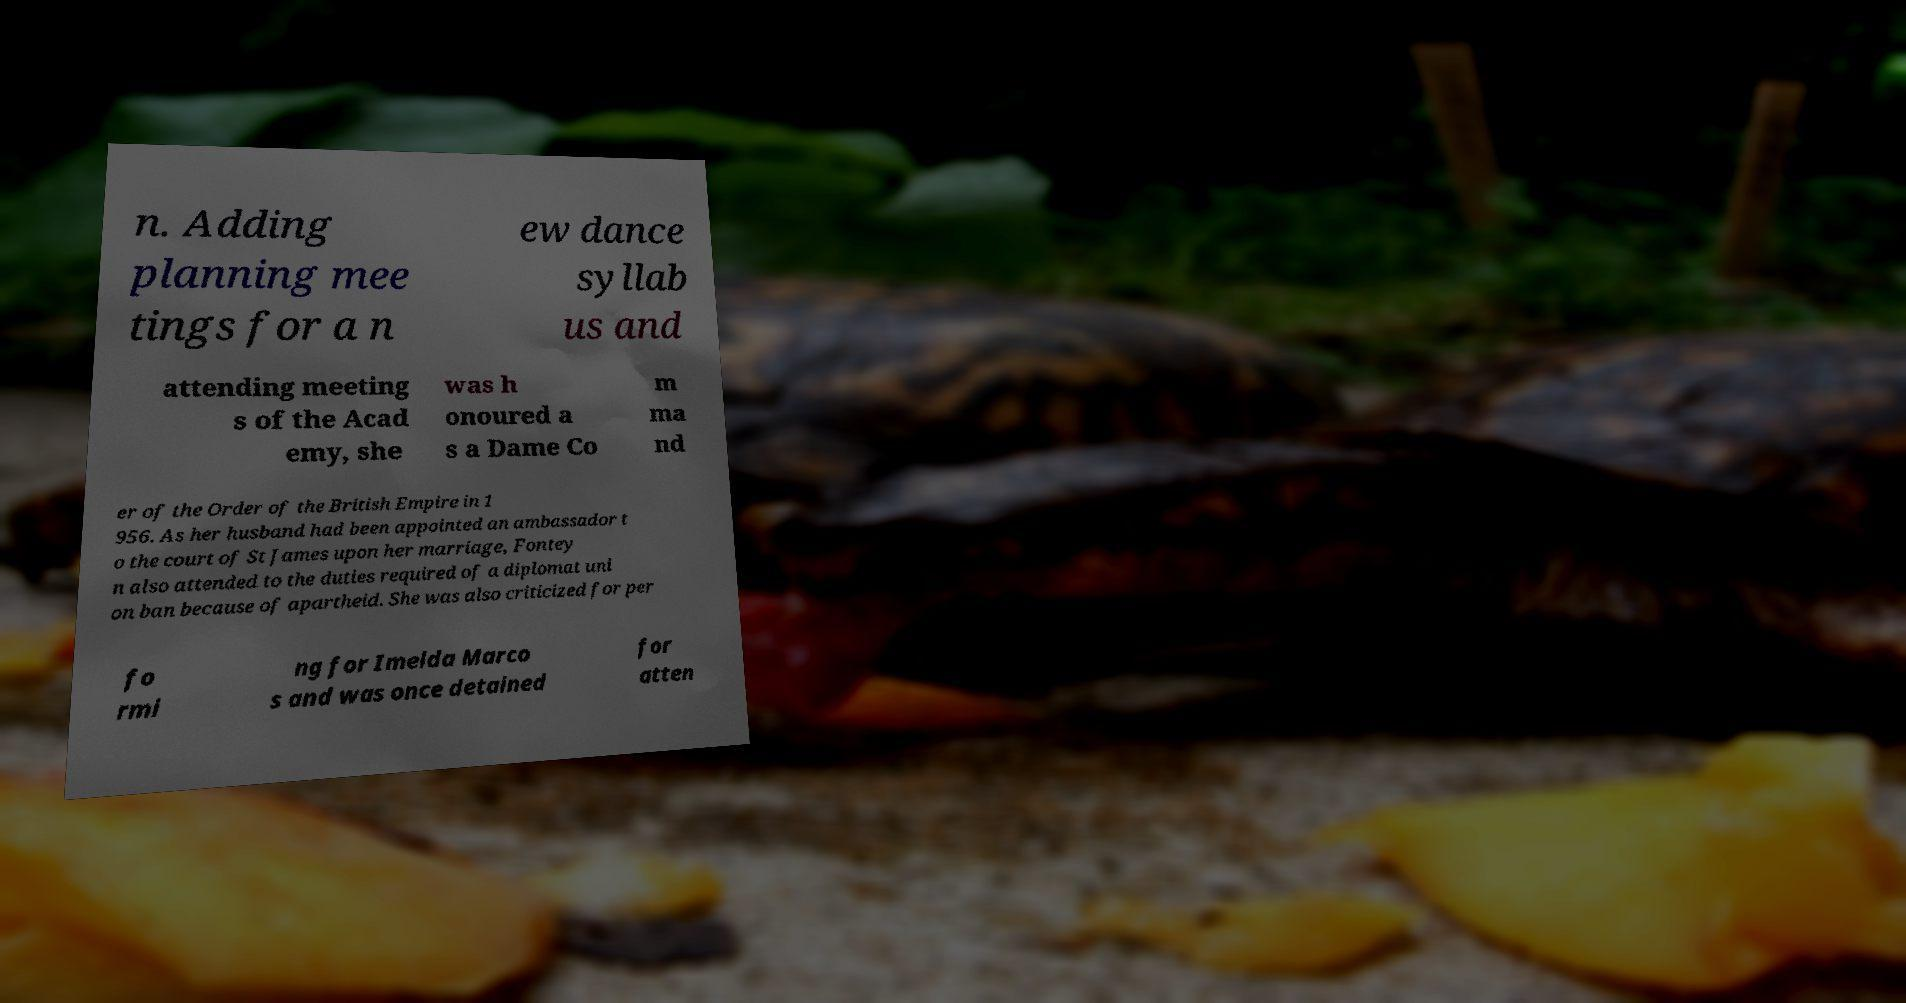Please read and relay the text visible in this image. What does it say? n. Adding planning mee tings for a n ew dance syllab us and attending meeting s of the Acad emy, she was h onoured a s a Dame Co m ma nd er of the Order of the British Empire in 1 956. As her husband had been appointed an ambassador t o the court of St James upon her marriage, Fontey n also attended to the duties required of a diplomat uni on ban because of apartheid. She was also criticized for per fo rmi ng for Imelda Marco s and was once detained for atten 